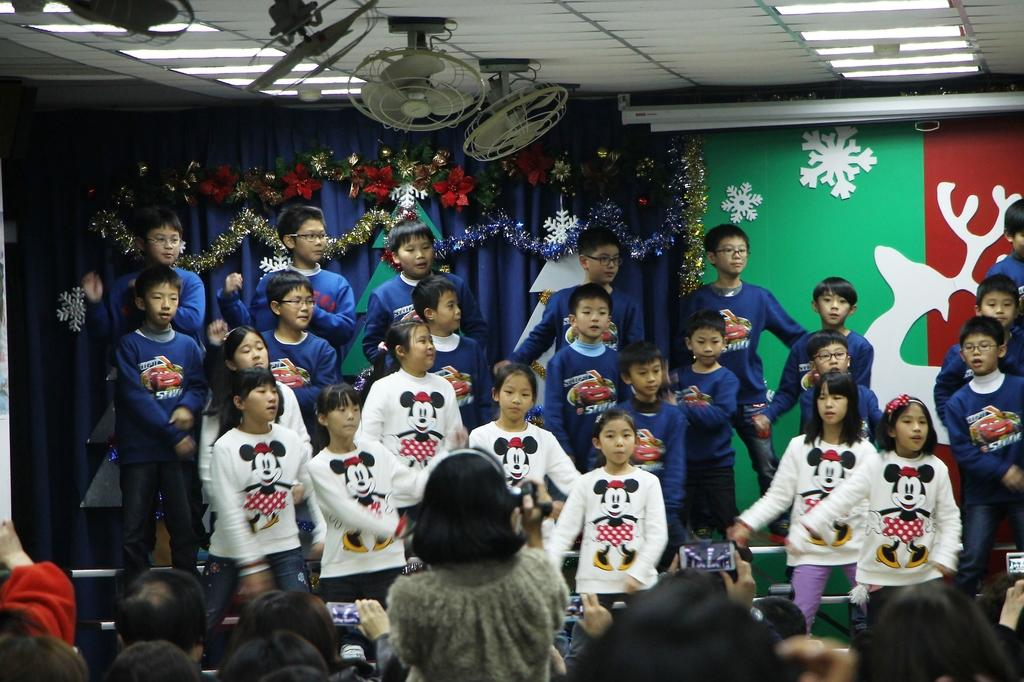How many people are in the image? There is a group of people in the image. What can be seen in the image that might be used for cooling? Fans are visible in the image. What is present in the image that might provide illumination? Lights are present in the image. What type of items can be seen in the image that serve a decorative purpose? Decorative items are in the image. What color are the curtains in the image? Blue color curtains are in the image. What type of structure is visible in the image? There is a wall in the image. What type of electronic device is present in the image? Mobile phones are present in the image. What type of oven is used in the image? There is no oven present in the image. How does the mind of the person in the image work? The image does not provide any information about the thoughts or mental processes of the people in the image. 